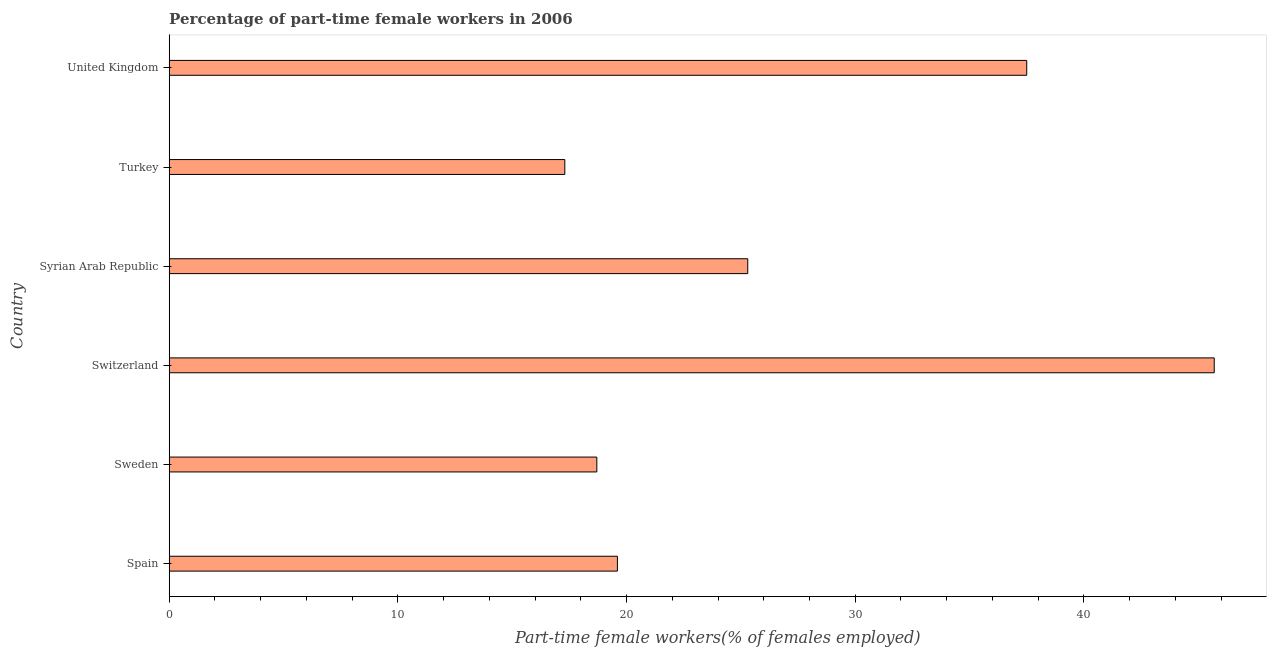Does the graph contain any zero values?
Offer a very short reply. No. What is the title of the graph?
Your answer should be very brief. Percentage of part-time female workers in 2006. What is the label or title of the X-axis?
Your answer should be very brief. Part-time female workers(% of females employed). What is the percentage of part-time female workers in Syrian Arab Republic?
Keep it short and to the point. 25.3. Across all countries, what is the maximum percentage of part-time female workers?
Offer a terse response. 45.7. Across all countries, what is the minimum percentage of part-time female workers?
Your answer should be very brief. 17.3. In which country was the percentage of part-time female workers maximum?
Offer a very short reply. Switzerland. What is the sum of the percentage of part-time female workers?
Offer a terse response. 164.1. What is the difference between the percentage of part-time female workers in Sweden and Syrian Arab Republic?
Ensure brevity in your answer.  -6.6. What is the average percentage of part-time female workers per country?
Your answer should be compact. 27.35. What is the median percentage of part-time female workers?
Make the answer very short. 22.45. In how many countries, is the percentage of part-time female workers greater than 6 %?
Your answer should be very brief. 6. What is the ratio of the percentage of part-time female workers in Sweden to that in Syrian Arab Republic?
Your answer should be very brief. 0.74. What is the difference between the highest and the lowest percentage of part-time female workers?
Ensure brevity in your answer.  28.4. Are all the bars in the graph horizontal?
Your answer should be very brief. Yes. Are the values on the major ticks of X-axis written in scientific E-notation?
Your answer should be very brief. No. What is the Part-time female workers(% of females employed) of Spain?
Keep it short and to the point. 19.6. What is the Part-time female workers(% of females employed) in Sweden?
Keep it short and to the point. 18.7. What is the Part-time female workers(% of females employed) in Switzerland?
Offer a very short reply. 45.7. What is the Part-time female workers(% of females employed) of Syrian Arab Republic?
Your answer should be very brief. 25.3. What is the Part-time female workers(% of females employed) of Turkey?
Your answer should be very brief. 17.3. What is the Part-time female workers(% of females employed) in United Kingdom?
Give a very brief answer. 37.5. What is the difference between the Part-time female workers(% of females employed) in Spain and Sweden?
Ensure brevity in your answer.  0.9. What is the difference between the Part-time female workers(% of females employed) in Spain and Switzerland?
Offer a terse response. -26.1. What is the difference between the Part-time female workers(% of females employed) in Spain and Turkey?
Your answer should be compact. 2.3. What is the difference between the Part-time female workers(% of females employed) in Spain and United Kingdom?
Provide a succinct answer. -17.9. What is the difference between the Part-time female workers(% of females employed) in Sweden and Switzerland?
Your answer should be compact. -27. What is the difference between the Part-time female workers(% of females employed) in Sweden and Syrian Arab Republic?
Offer a terse response. -6.6. What is the difference between the Part-time female workers(% of females employed) in Sweden and Turkey?
Offer a very short reply. 1.4. What is the difference between the Part-time female workers(% of females employed) in Sweden and United Kingdom?
Provide a short and direct response. -18.8. What is the difference between the Part-time female workers(% of females employed) in Switzerland and Syrian Arab Republic?
Give a very brief answer. 20.4. What is the difference between the Part-time female workers(% of females employed) in Switzerland and Turkey?
Provide a succinct answer. 28.4. What is the difference between the Part-time female workers(% of females employed) in Switzerland and United Kingdom?
Offer a very short reply. 8.2. What is the difference between the Part-time female workers(% of females employed) in Syrian Arab Republic and Turkey?
Your response must be concise. 8. What is the difference between the Part-time female workers(% of females employed) in Turkey and United Kingdom?
Offer a terse response. -20.2. What is the ratio of the Part-time female workers(% of females employed) in Spain to that in Sweden?
Keep it short and to the point. 1.05. What is the ratio of the Part-time female workers(% of females employed) in Spain to that in Switzerland?
Ensure brevity in your answer.  0.43. What is the ratio of the Part-time female workers(% of females employed) in Spain to that in Syrian Arab Republic?
Your response must be concise. 0.78. What is the ratio of the Part-time female workers(% of females employed) in Spain to that in Turkey?
Your response must be concise. 1.13. What is the ratio of the Part-time female workers(% of females employed) in Spain to that in United Kingdom?
Provide a succinct answer. 0.52. What is the ratio of the Part-time female workers(% of females employed) in Sweden to that in Switzerland?
Give a very brief answer. 0.41. What is the ratio of the Part-time female workers(% of females employed) in Sweden to that in Syrian Arab Republic?
Your answer should be very brief. 0.74. What is the ratio of the Part-time female workers(% of females employed) in Sweden to that in Turkey?
Offer a terse response. 1.08. What is the ratio of the Part-time female workers(% of females employed) in Sweden to that in United Kingdom?
Your response must be concise. 0.5. What is the ratio of the Part-time female workers(% of females employed) in Switzerland to that in Syrian Arab Republic?
Provide a succinct answer. 1.81. What is the ratio of the Part-time female workers(% of females employed) in Switzerland to that in Turkey?
Offer a terse response. 2.64. What is the ratio of the Part-time female workers(% of females employed) in Switzerland to that in United Kingdom?
Make the answer very short. 1.22. What is the ratio of the Part-time female workers(% of females employed) in Syrian Arab Republic to that in Turkey?
Give a very brief answer. 1.46. What is the ratio of the Part-time female workers(% of females employed) in Syrian Arab Republic to that in United Kingdom?
Ensure brevity in your answer.  0.68. What is the ratio of the Part-time female workers(% of females employed) in Turkey to that in United Kingdom?
Your answer should be very brief. 0.46. 